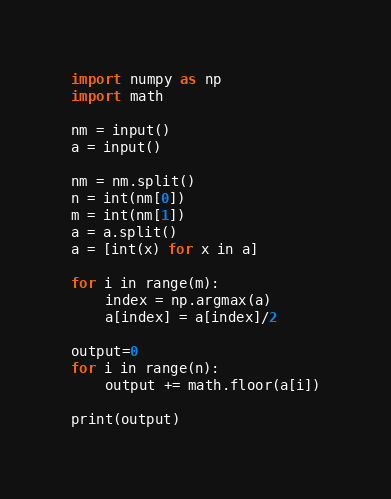<code> <loc_0><loc_0><loc_500><loc_500><_Python_>import numpy as np
import math

nm = input()
a = input()

nm = nm.split()
n = int(nm[0])
m = int(nm[1])
a = a.split()
a = [int(x) for x in a]

for i in range(m):
    index = np.argmax(a)
    a[index] = a[index]/2

output=0
for i in range(n):
    output += math.floor(a[i])

print(output)
</code> 